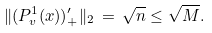Convert formula to latex. <formula><loc_0><loc_0><loc_500><loc_500>\| ( P ^ { 1 } _ { v } ( x ) ) ^ { \prime } _ { + } \| _ { 2 } \, = \, \sqrt { n } \leq \sqrt { M } .</formula> 